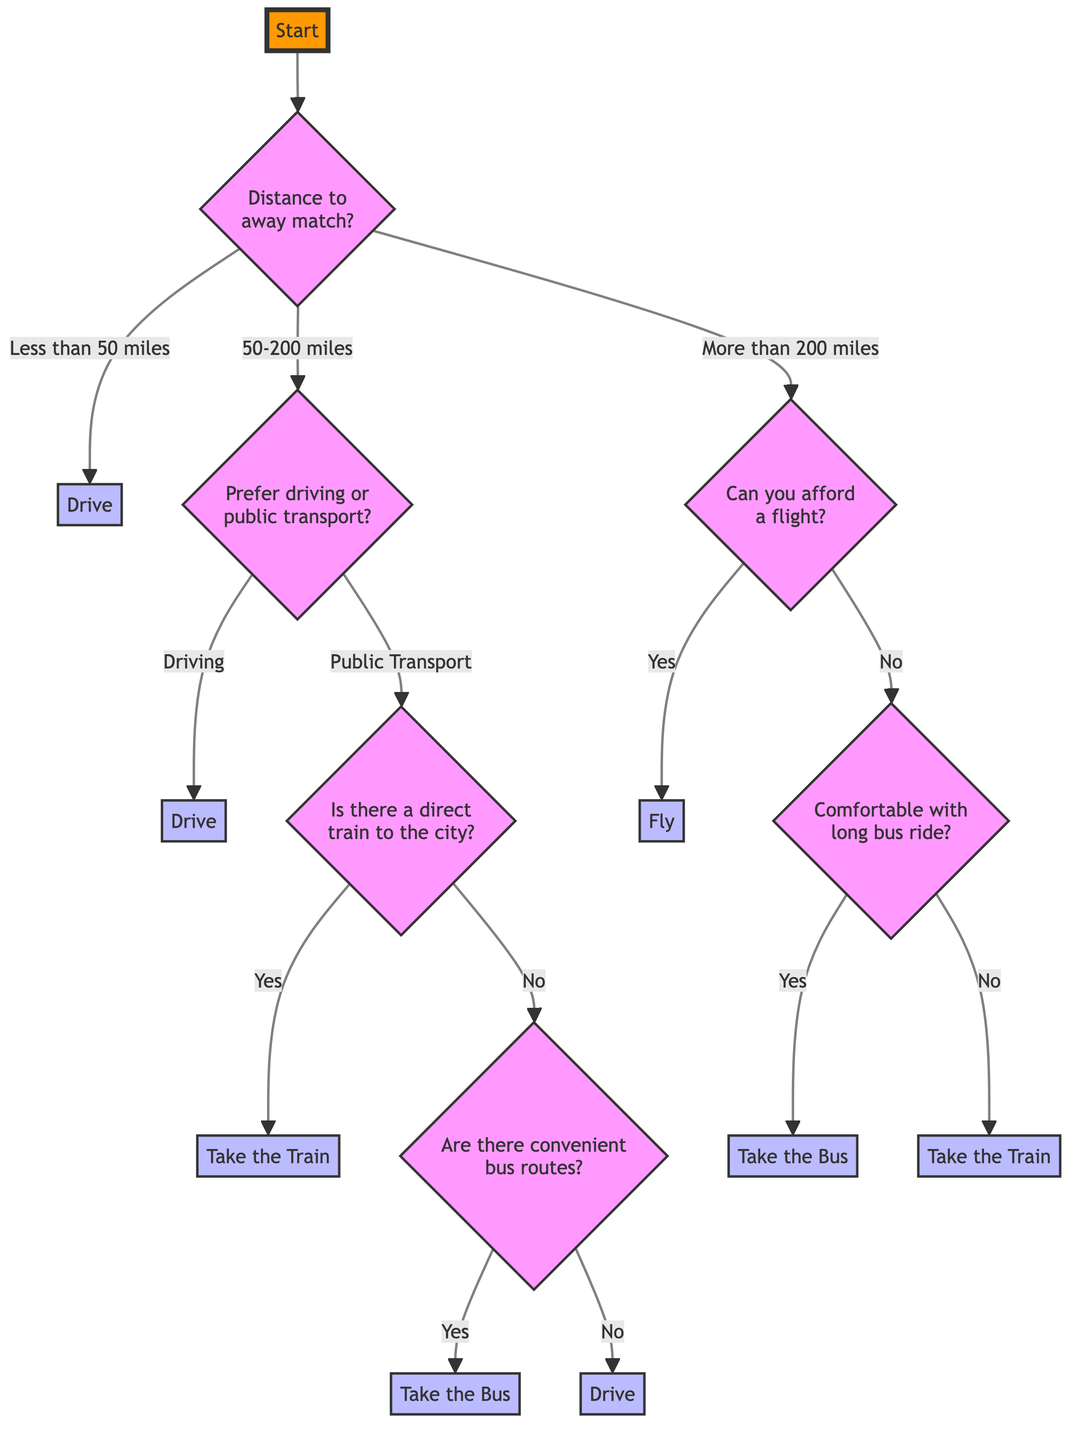What is the first question in the decision tree? The first question in the decision tree is located at the "Start" node, and it asks about the distance to the away match.
Answer: What is the distance to the away match? What happens if the distance is less than 50 miles? According to the diagram, if the distance to the away match is less than 50 miles, the decision is to "Drive."
Answer: Drive How many main branches does the decision tree have? The decision tree has three main branches based on the distance options: "Less than 50 miles," "50-200 miles," and "More than 200 miles."
Answer: 3 If the distance is between 50 and 200 miles and a person prefers public transport, what is the next question they will face? If someone prefers public transport with a distance of 50-200 miles, the next question is whether there is a direct train to the city.
Answer: Is there a direct train to the city? What will be the final decision if a person cannot afford a flight for a match over 200 miles and is not comfortable with a long bus ride? If a person cannot afford a flight for a distance over 200 miles and is also not comfortable with a long bus ride, the decision will be to "Take the Train."
Answer: Take the Train What question follows if the distance is more than 200 miles and the person can afford a flight? If someone can afford a flight for a distance over 200 miles, the next decision questions do not follow; the answer is simply to "Fly."
Answer: Fly What option do you choose if there is no direct train and no convenient bus routes for a distance of 50-200 miles? If there is no direct train and no convenient bus routes, the option will be to "Drive."
Answer: Drive What type of transport is chosen if the distance is more than 200 miles and a person is comfortable with a long bus ride? If the distance is more than 200 miles and the person is comfortable with a long bus ride, they will choose to "Take the Bus."
Answer: Take the Bus 